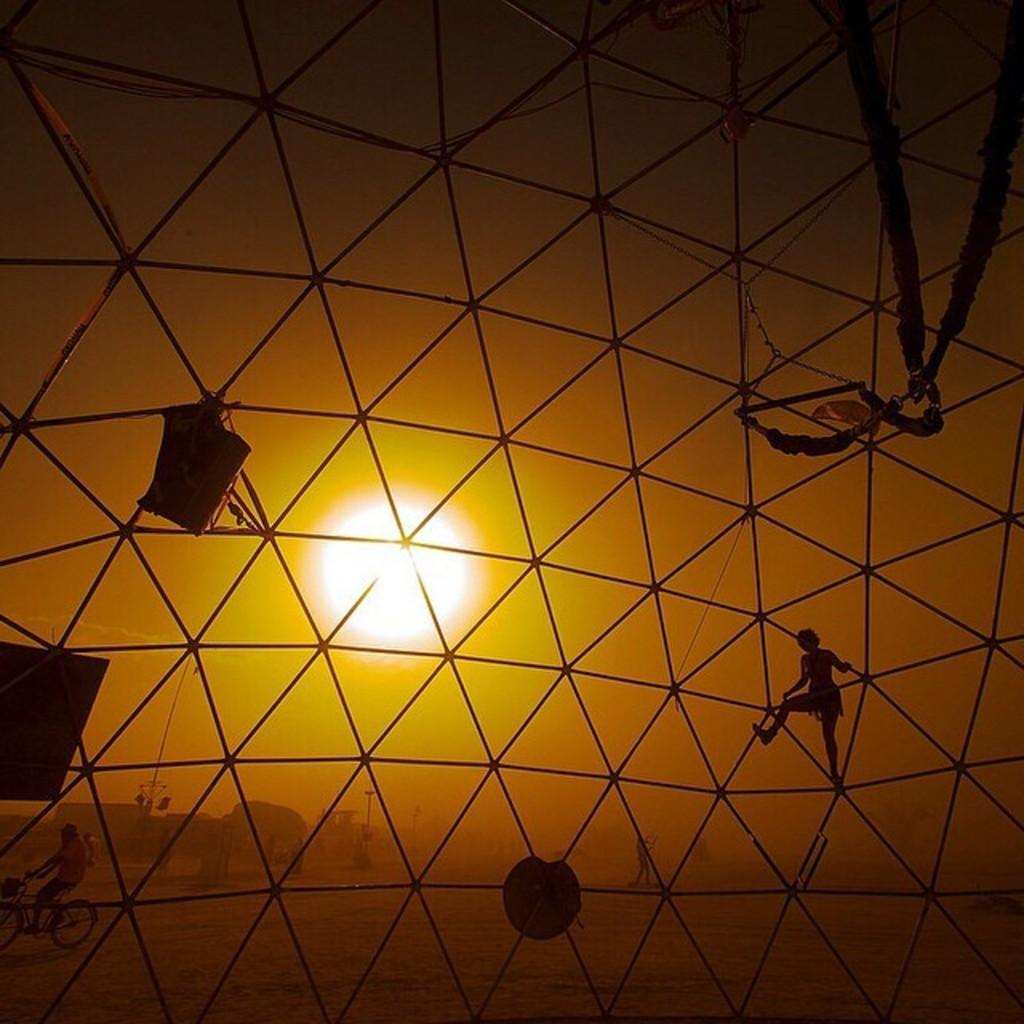What is the main feature of the image? There is a mesh in the image. What can be seen through the mesh? People and objects are visible through the mesh. What is the weather like in the image? There is sun in the image, suggesting a clear day. How many rabbits can be seen hopping through the mesh in the image? There are no rabbits present in the image. What type of spade is being used to dig through the mesh in the image? There is no spade or digging activity depicted in the image. 